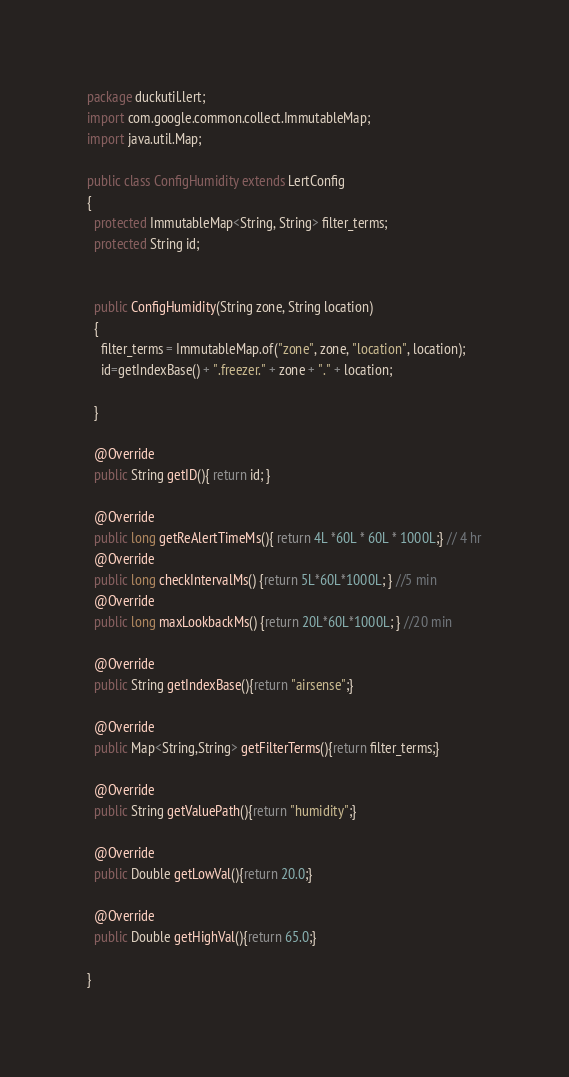<code> <loc_0><loc_0><loc_500><loc_500><_Java_>package duckutil.lert;
import com.google.common.collect.ImmutableMap;
import java.util.Map;

public class ConfigHumidity extends LertConfig
{
  protected ImmutableMap<String, String> filter_terms;
  protected String id;


  public ConfigHumidity(String zone, String location)
  {
    filter_terms = ImmutableMap.of("zone", zone, "location", location);
    id=getIndexBase() + ".freezer." + zone + "." + location;

  }

  @Override
  public String getID(){ return id; }

  @Override
  public long getReAlertTimeMs(){ return 4L *60L * 60L * 1000L;} // 4 hr
  @Override
  public long checkIntervalMs() {return 5L*60L*1000L; } //5 min 
  @Override
  public long maxLookbackMs() {return 20L*60L*1000L; } //20 min

  @Override
  public String getIndexBase(){return "airsense";}

  @Override
  public Map<String,String> getFilterTerms(){return filter_terms;}

  @Override
  public String getValuePath(){return "humidity";}

  @Override
  public Double getLowVal(){return 20.0;}

  @Override
  public Double getHighVal(){return 65.0;}

}
</code> 